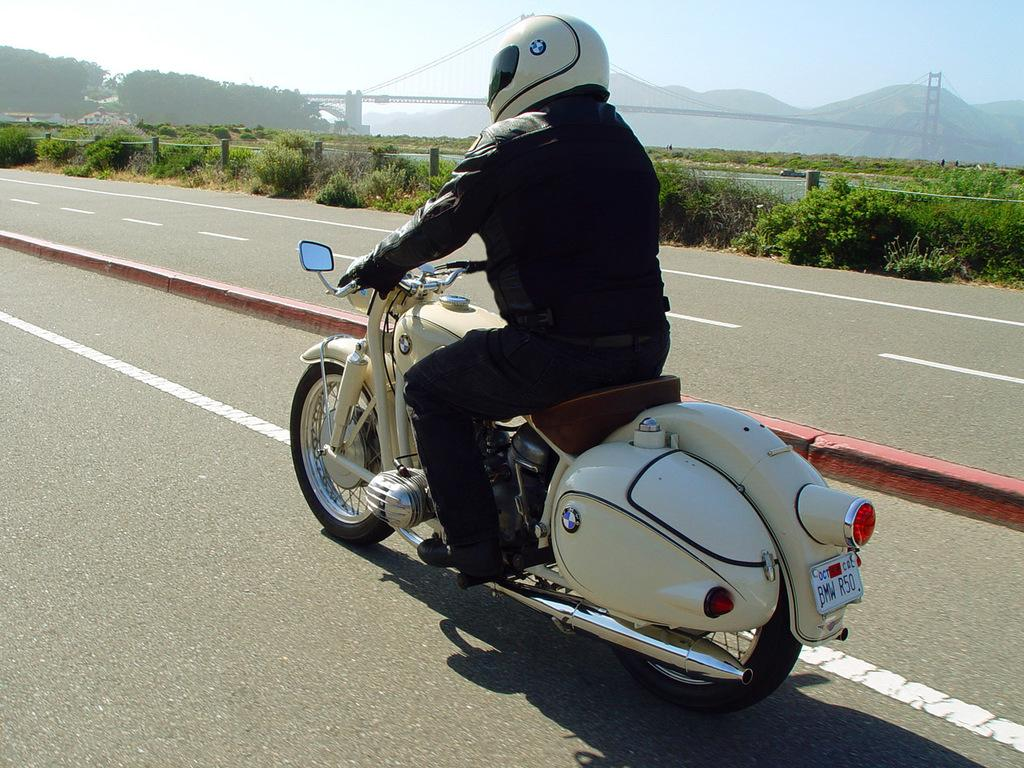What is the person doing in the image? The person is riding a motorcycle in the image. Where is the person located? The person is outside of the city in the image. What is the person wearing? The person is wearing a black jacket and a helmet in the image. What can be seen in the background of the image? There is sky, a tree, a mountain, and a bridge visible in the background of the image. What type of plantation can be seen in the background of the image? There is no plantation visible in the background of the image. Is there a rabbit hopping near the motorcycle in the image? There is no rabbit present in the image. 